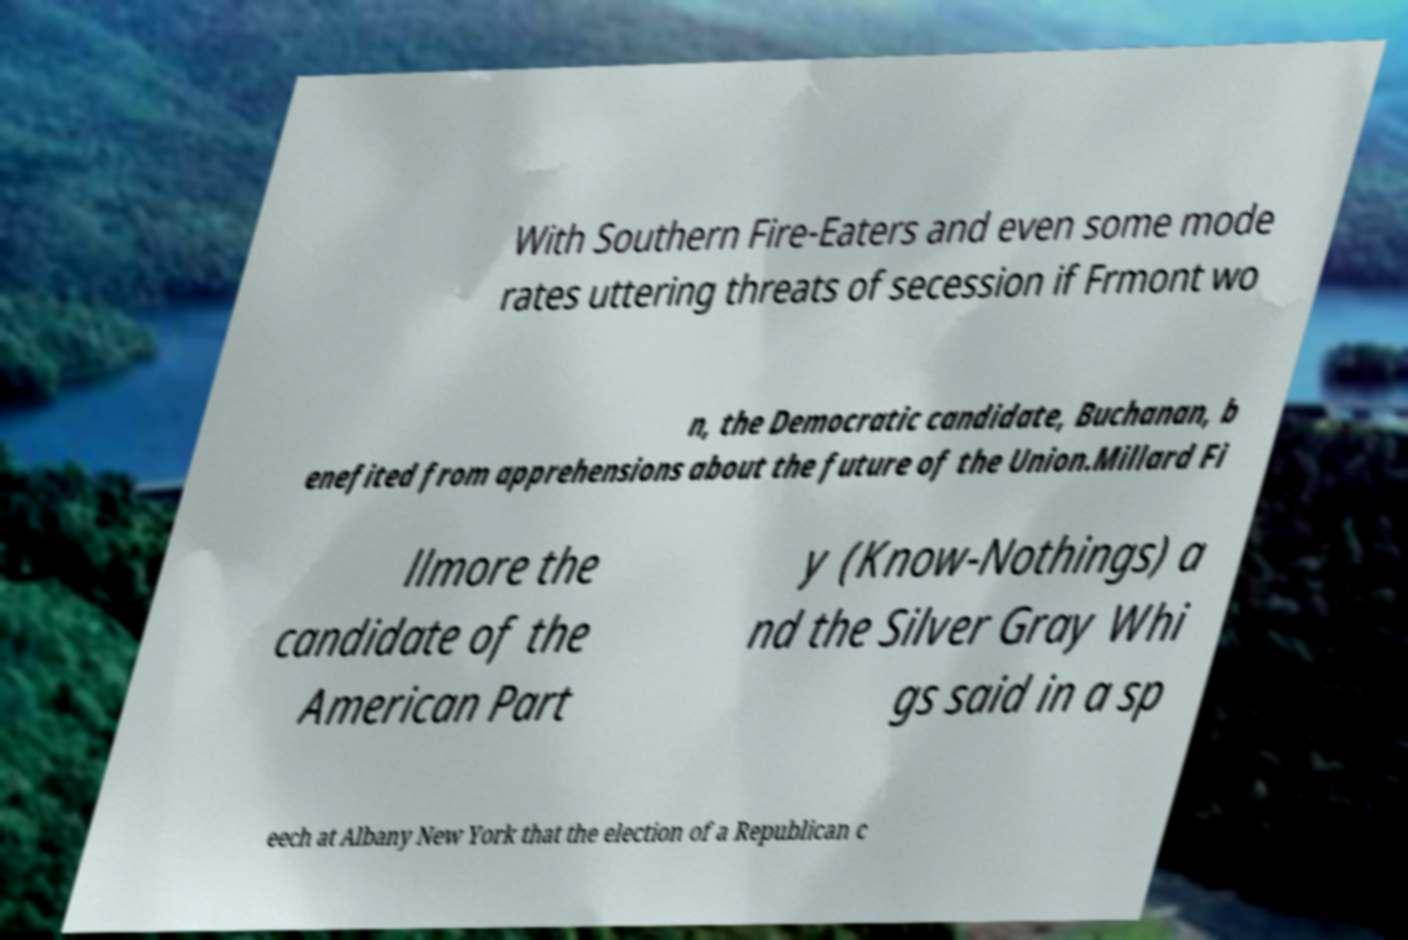There's text embedded in this image that I need extracted. Can you transcribe it verbatim? With Southern Fire-Eaters and even some mode rates uttering threats of secession if Frmont wo n, the Democratic candidate, Buchanan, b enefited from apprehensions about the future of the Union.Millard Fi llmore the candidate of the American Part y (Know-Nothings) a nd the Silver Gray Whi gs said in a sp eech at Albany New York that the election of a Republican c 